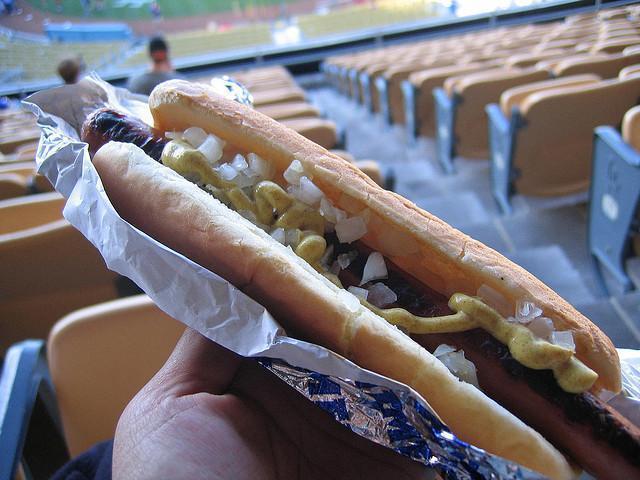How many hot dogs are there?
Give a very brief answer. 1. 